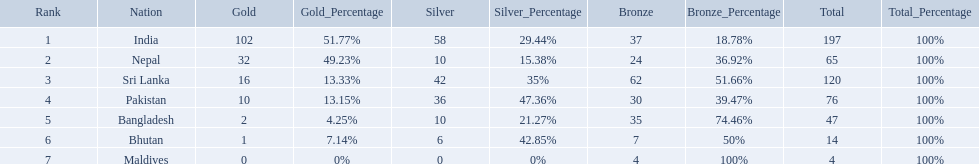Which countries won medals? India, Nepal, Sri Lanka, Pakistan, Bangladesh, Bhutan, Maldives. Which won the most? India. Which won the fewest? Maldives. What are the totals of medals one in each country? 197, 65, 120, 76, 47, 14, 4. Which of these totals are less than 10? 4. Who won this number of medals? Maldives. What are the nations? India, Nepal, Sri Lanka, Pakistan, Bangladesh, Bhutan, Maldives. Of these, which one has earned the least amount of gold medals? Maldives. Which nations played at the 1999 south asian games? India, Nepal, Sri Lanka, Pakistan, Bangladesh, Bhutan, Maldives. Which country is listed second in the table? Nepal. 